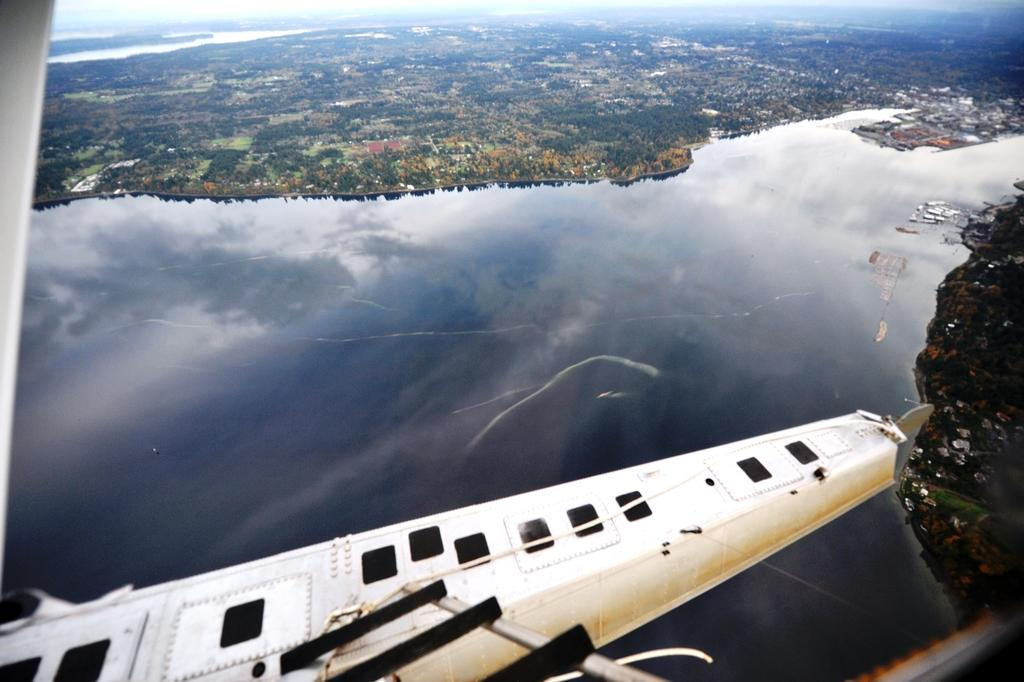What is the main subject of the image? The main subject of the image is an airplane flying in the air. What can be seen in the background of the image? There is water, trees, and buildings visible in the image. What type of kettle can be seen in the image? There is no kettle present in the image. What form does the distribution of water take in the image? The image does not show the distribution of water; it only shows water visible in the background. 